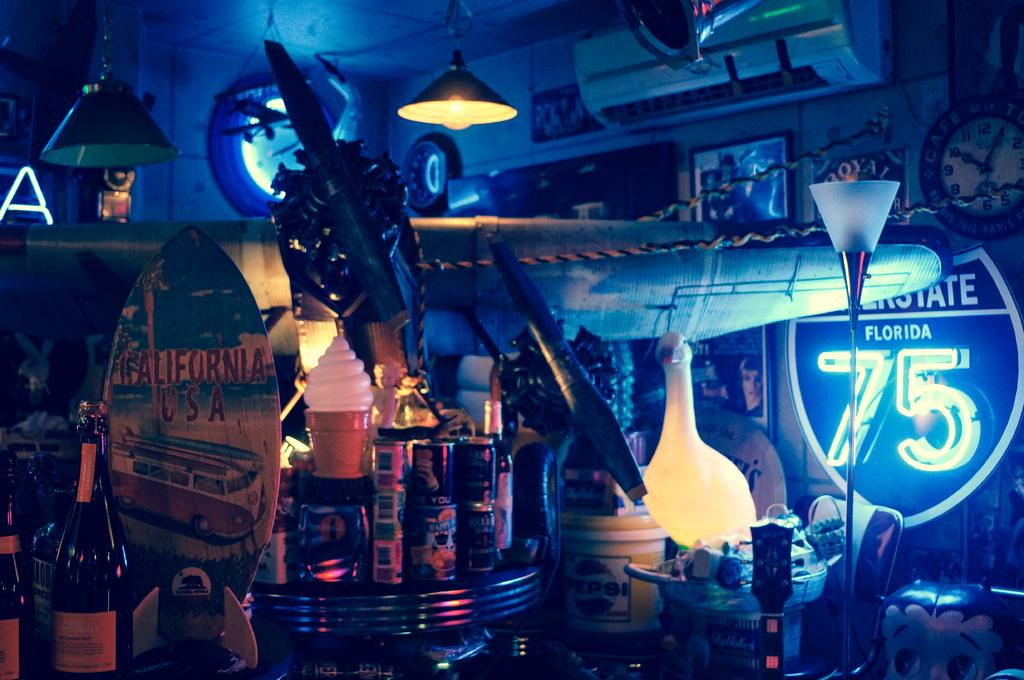Provide a one-sentence caption for the provided image. Room frilled with a bunch of junk including a glowing sign that says 75 on it. 